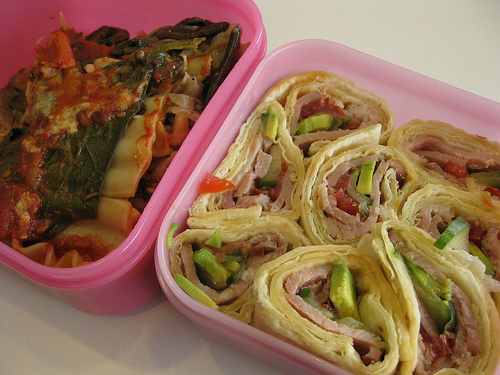<image>
Is there a food in the box? No. The food is not contained within the box. These objects have a different spatial relationship. Is there a tupperware in front of the tupperware? Yes. The tupperware is positioned in front of the tupperware, appearing closer to the camera viewpoint. 